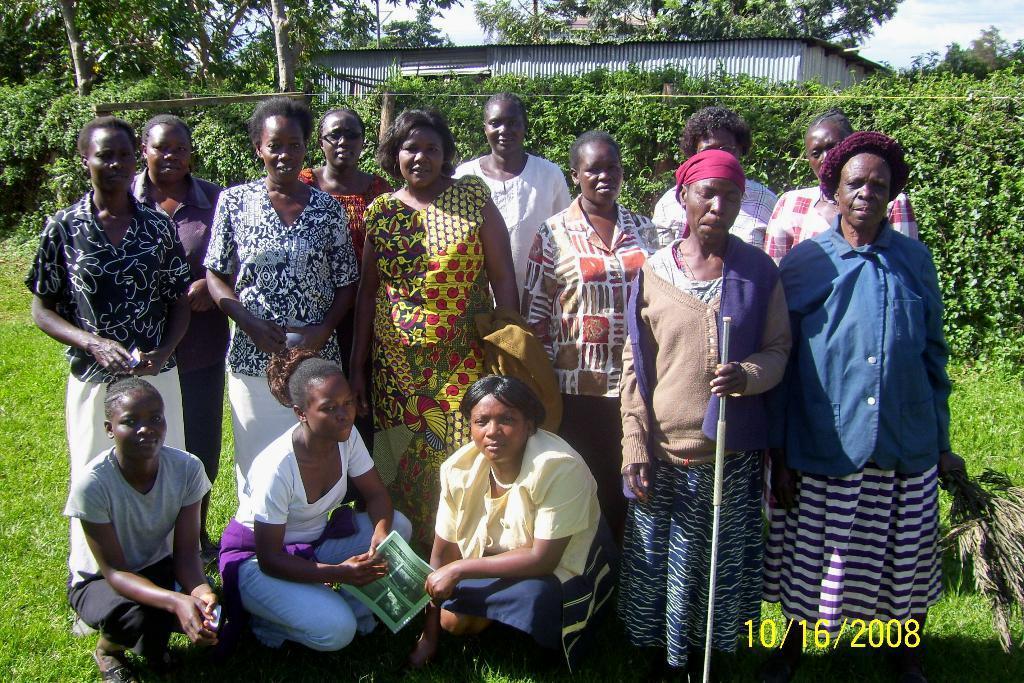Can you describe this image briefly? In the picture there are many people standing, there are three persons sitting in a squat position, behind them there are plants, there are trees, there is a shed, there is a clear sky. 